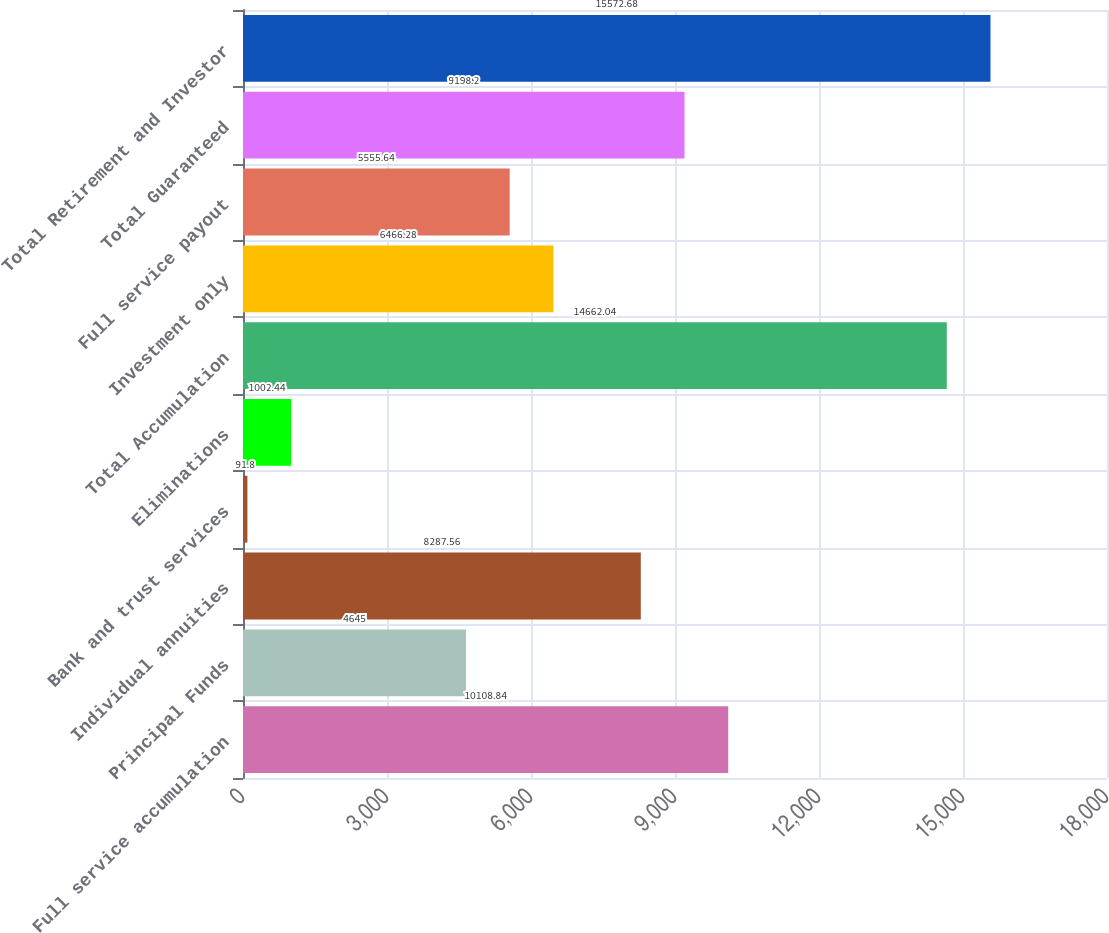<chart> <loc_0><loc_0><loc_500><loc_500><bar_chart><fcel>Full service accumulation<fcel>Principal Funds<fcel>Individual annuities<fcel>Bank and trust services<fcel>Eliminations<fcel>Total Accumulation<fcel>Investment only<fcel>Full service payout<fcel>Total Guaranteed<fcel>Total Retirement and Investor<nl><fcel>10108.8<fcel>4645<fcel>8287.56<fcel>91.8<fcel>1002.44<fcel>14662<fcel>6466.28<fcel>5555.64<fcel>9198.2<fcel>15572.7<nl></chart> 